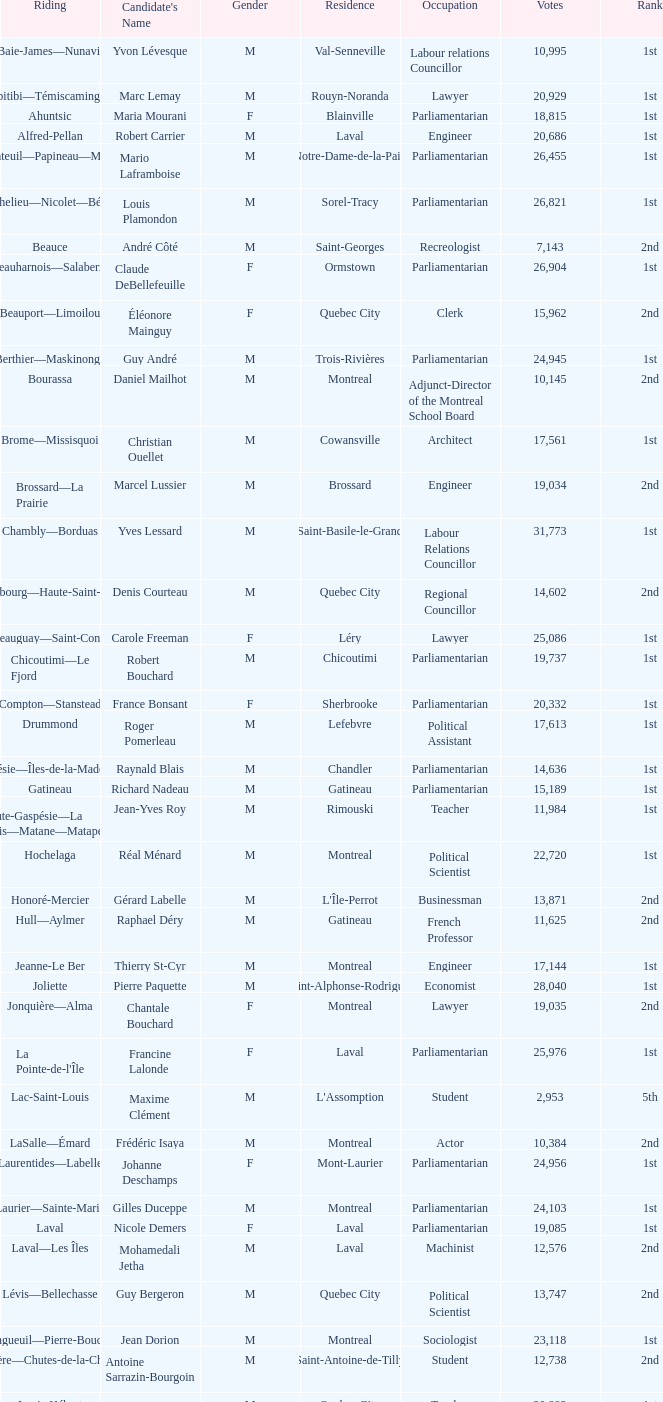What gender is Luc Desnoyers? M. 